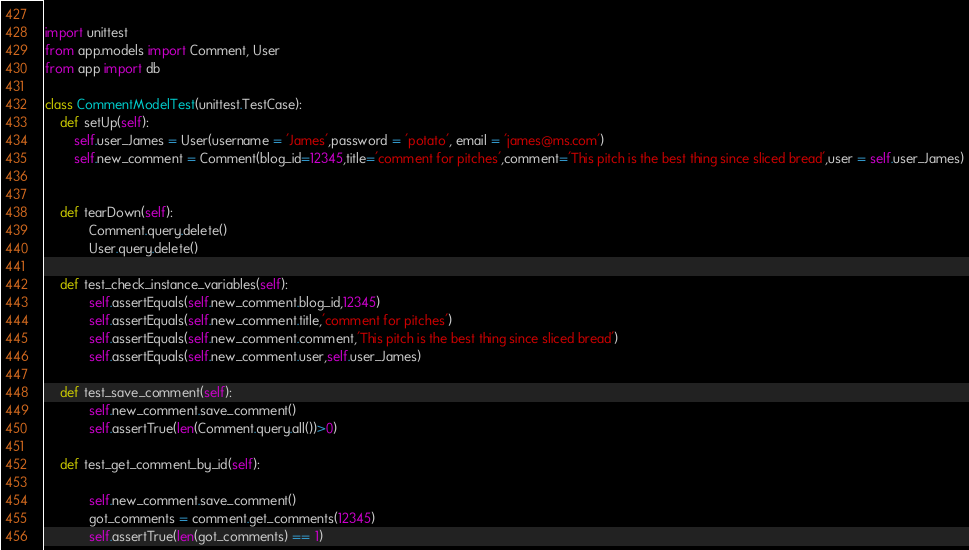Convert code to text. <code><loc_0><loc_0><loc_500><loc_500><_Python_> 
import unittest
from app.models import Comment, User
from app import db

class CommentModelTest(unittest.TestCase):
    def setUp(self):
        self.user_James = User(username = 'James',password = 'potato', email = 'james@ms.com')
        self.new_comment = Comment(blog_id=12345,title='comment for pitches',comment='This pitch is the best thing since sliced bread',user = self.user_James)


    def tearDown(self):
            Comment.query.delete()
            User.query.delete()

    def test_check_instance_variables(self):
            self.assertEquals(self.new_comment.blog_id,12345)
            self.assertEquals(self.new_comment.title,'comment for pitches')
            self.assertEquals(self.new_comment.comment,'This pitch is the best thing since sliced bread')
            self.assertEquals(self.new_comment.user,self.user_James)

    def test_save_comment(self):
            self.new_comment.save_comment()
            self.assertTrue(len(Comment.query.all())>0)

    def test_get_comment_by_id(self):

            self.new_comment.save_comment()
            got_comments = comment.get_comments(12345)
            self.assertTrue(len(got_comments) == 1)</code> 